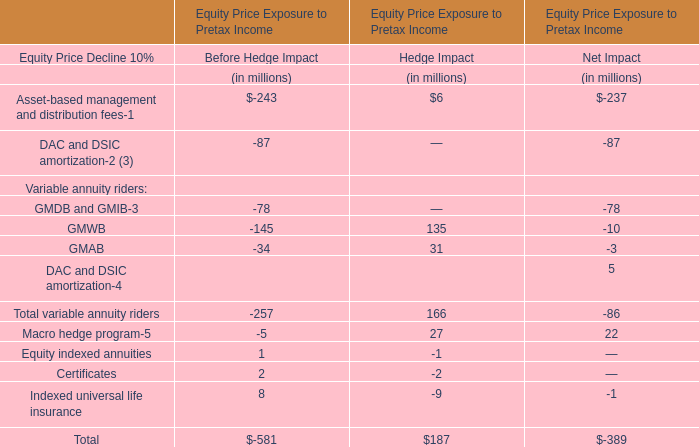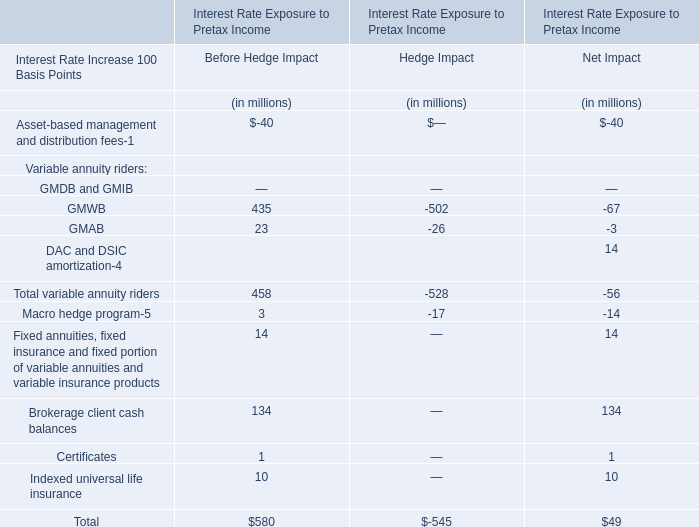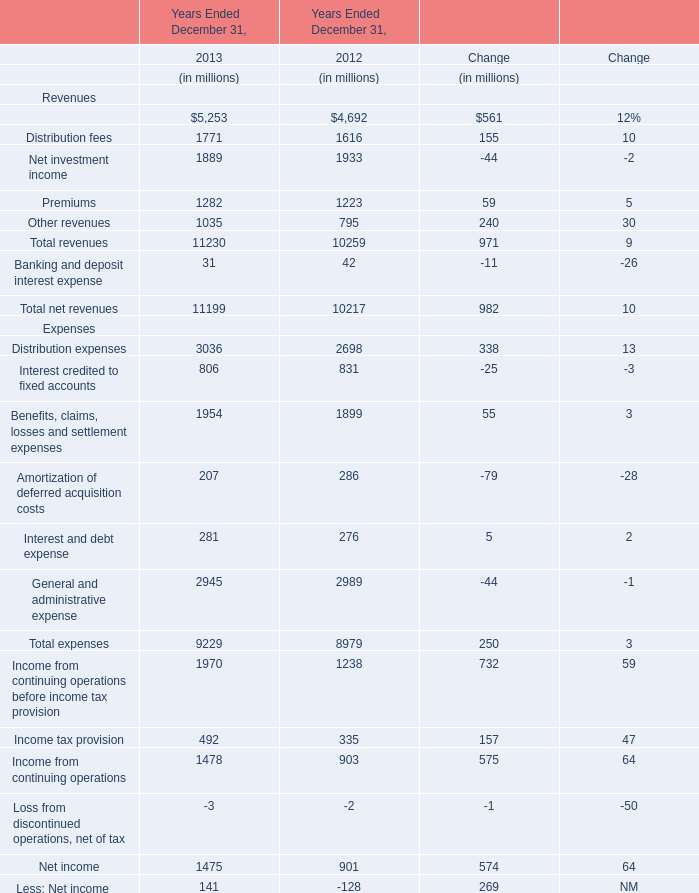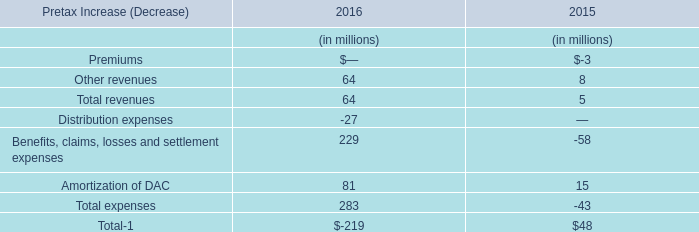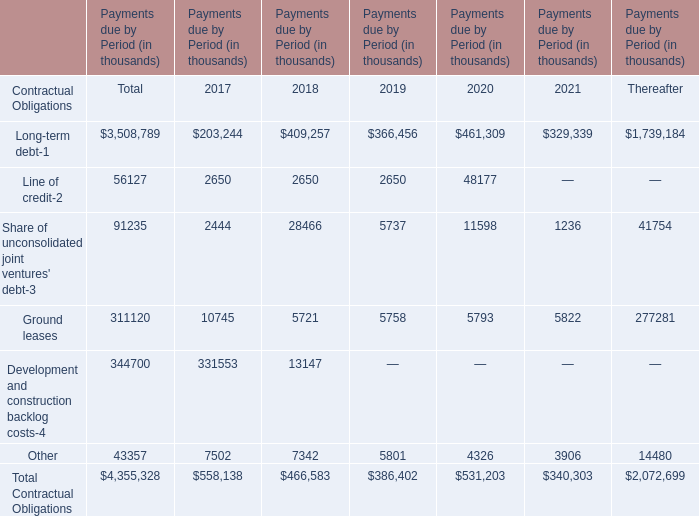What is the percentage of Long-term debt in relation to the total in 2018 ? 
Computations: (409257 / 466583)
Answer: 0.87714. 